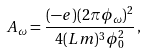Convert formula to latex. <formula><loc_0><loc_0><loc_500><loc_500>A _ { \omega } = \frac { ( - e ) ( 2 \pi \phi _ { \omega } ) ^ { 2 } } { 4 ( L m ) ^ { 3 } \phi _ { 0 } ^ { 2 } } \, ,</formula> 